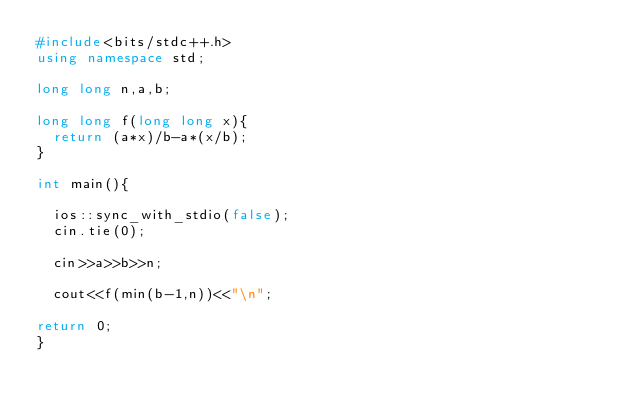<code> <loc_0><loc_0><loc_500><loc_500><_C++_>#include<bits/stdc++.h>
using namespace std;

long long n,a,b;

long long f(long long x){
	return (a*x)/b-a*(x/b);
}

int main(){

	ios::sync_with_stdio(false);
	cin.tie(0);

	cin>>a>>b>>n;
	
	cout<<f(min(b-1,n))<<"\n";

return 0;
}
</code> 